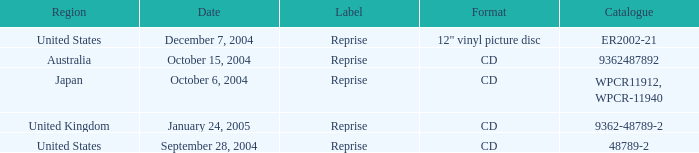What is the title of the catalog from october 15, 2004? 9362487892.0. 